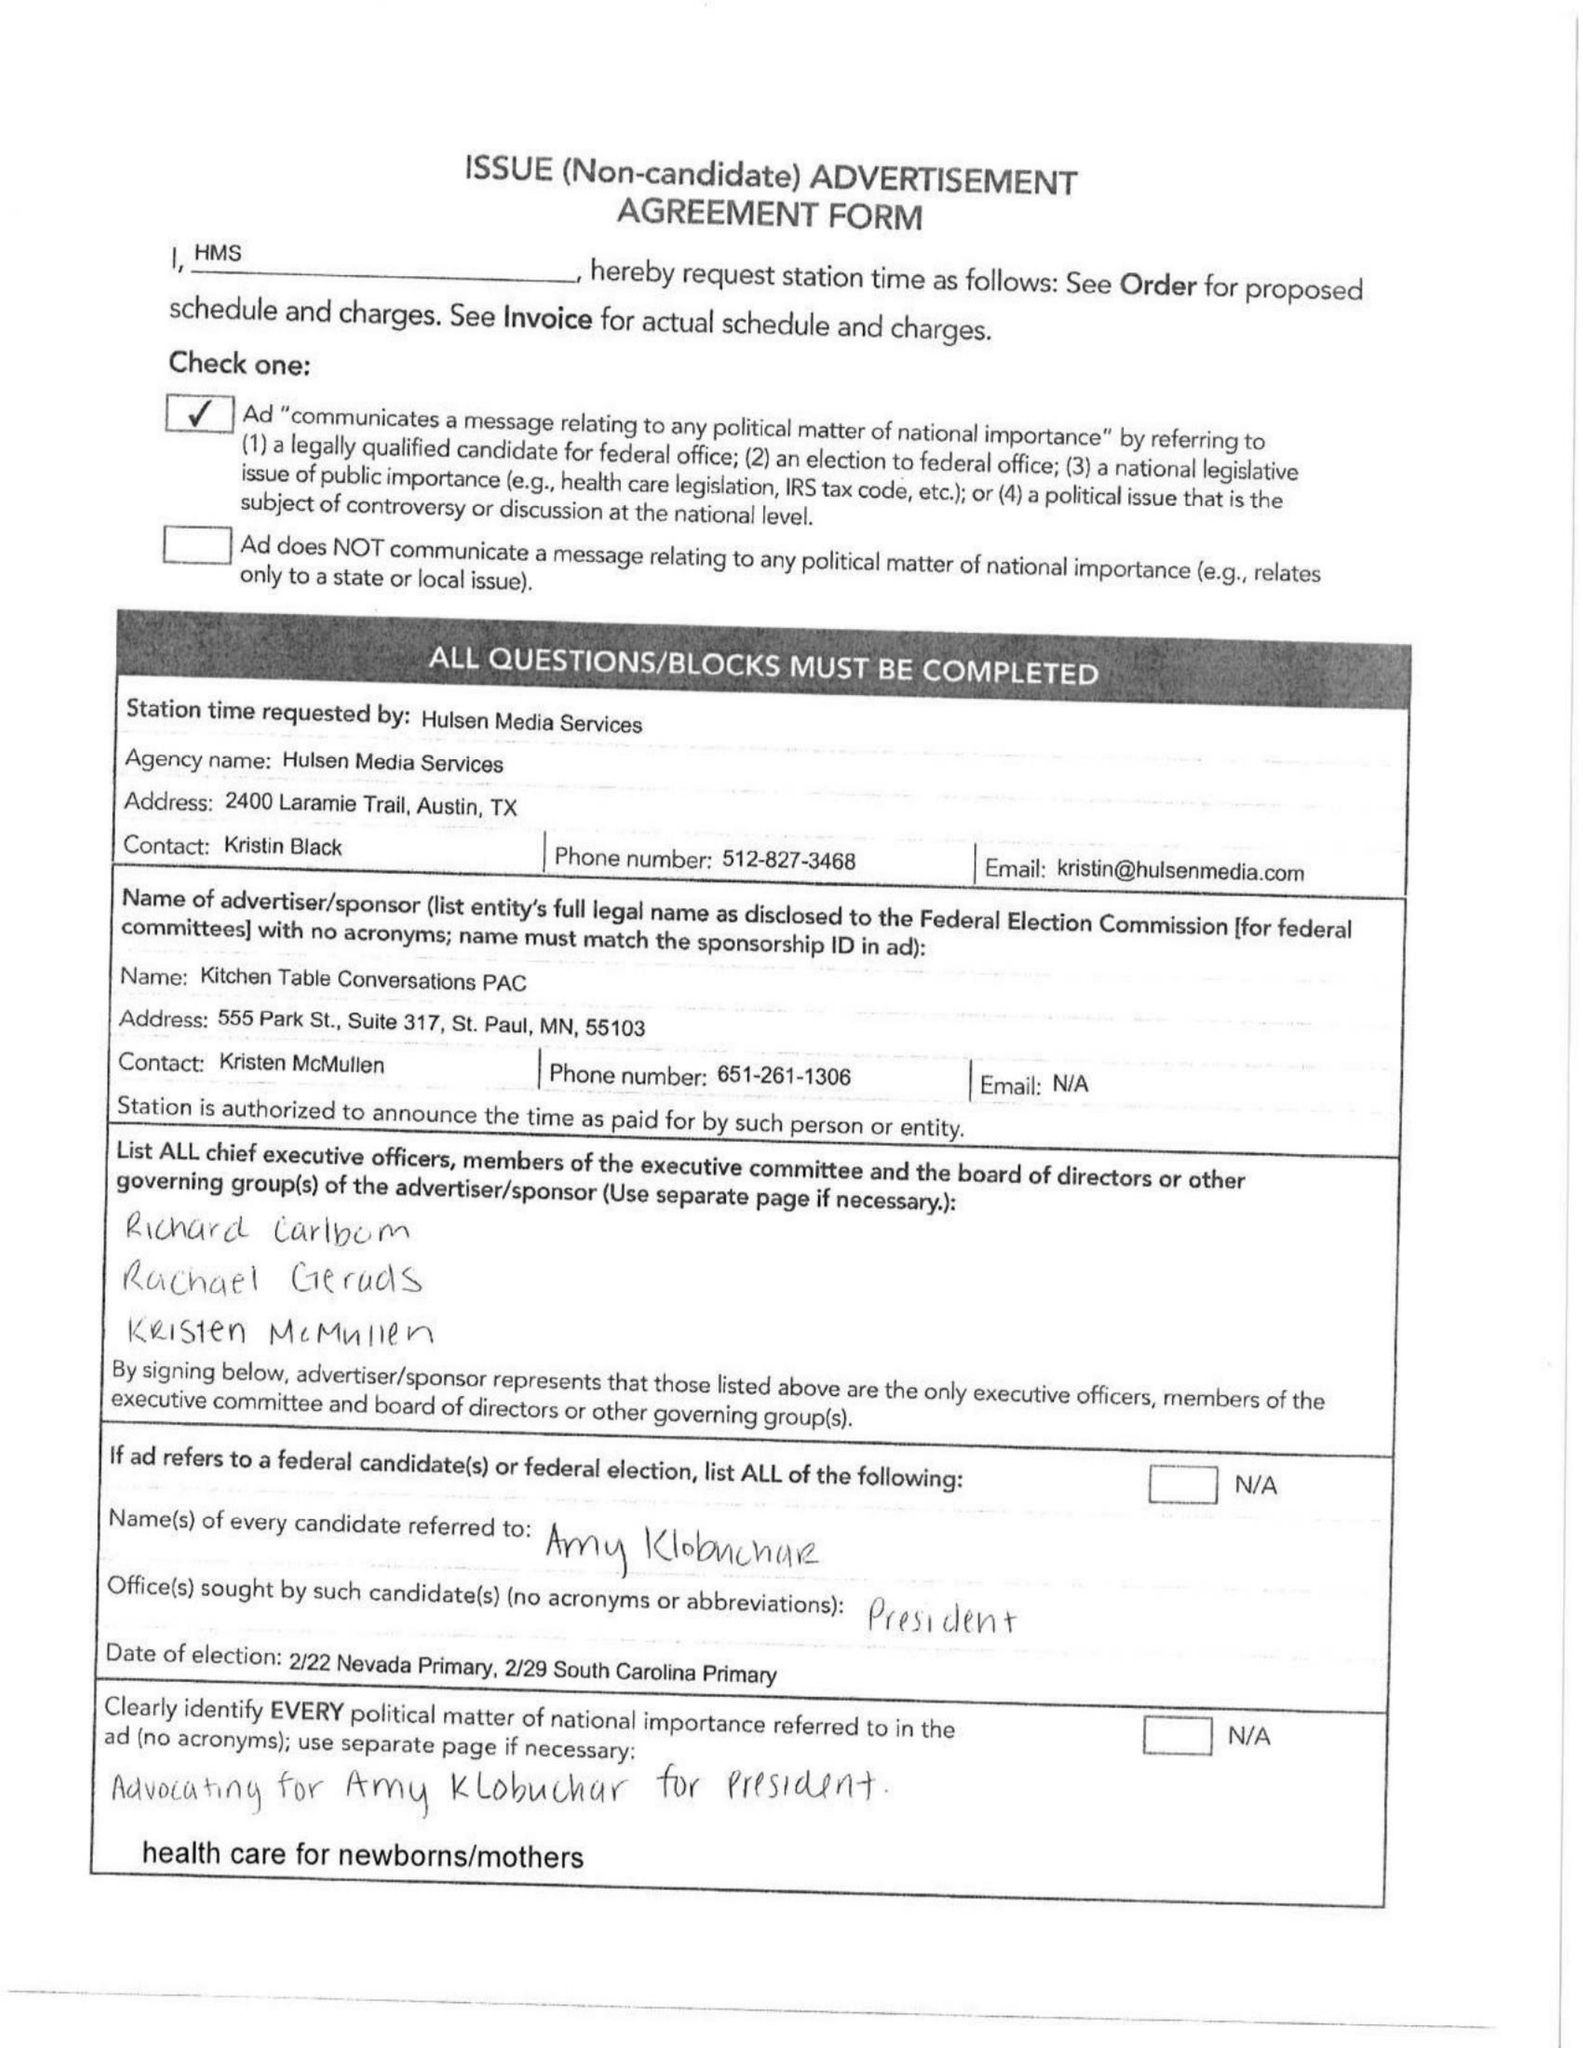What is the value for the advertiser?
Answer the question using a single word or phrase. KRISTIN BLACK 